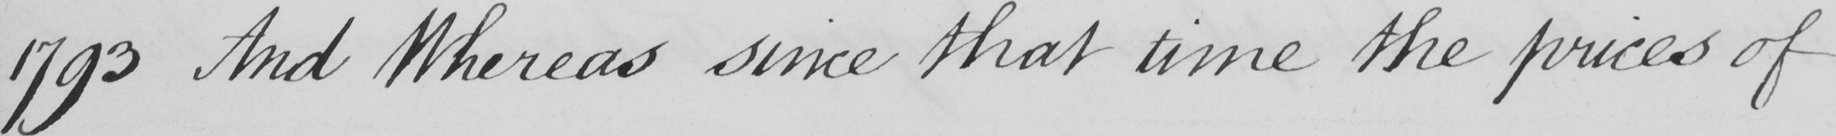What does this handwritten line say? 1793 And Whereas since that time the prices of 